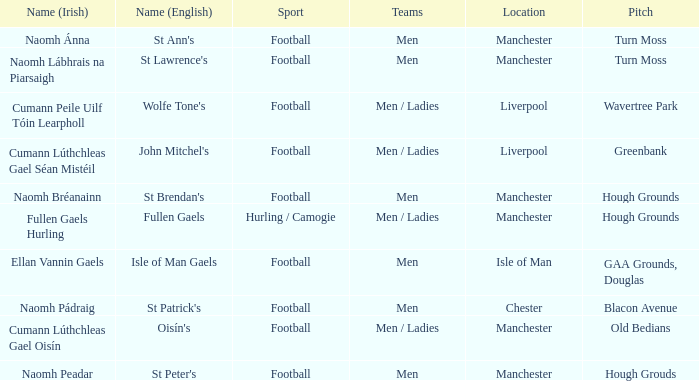What is the Location of the Old Bedians Pitch? Manchester. 